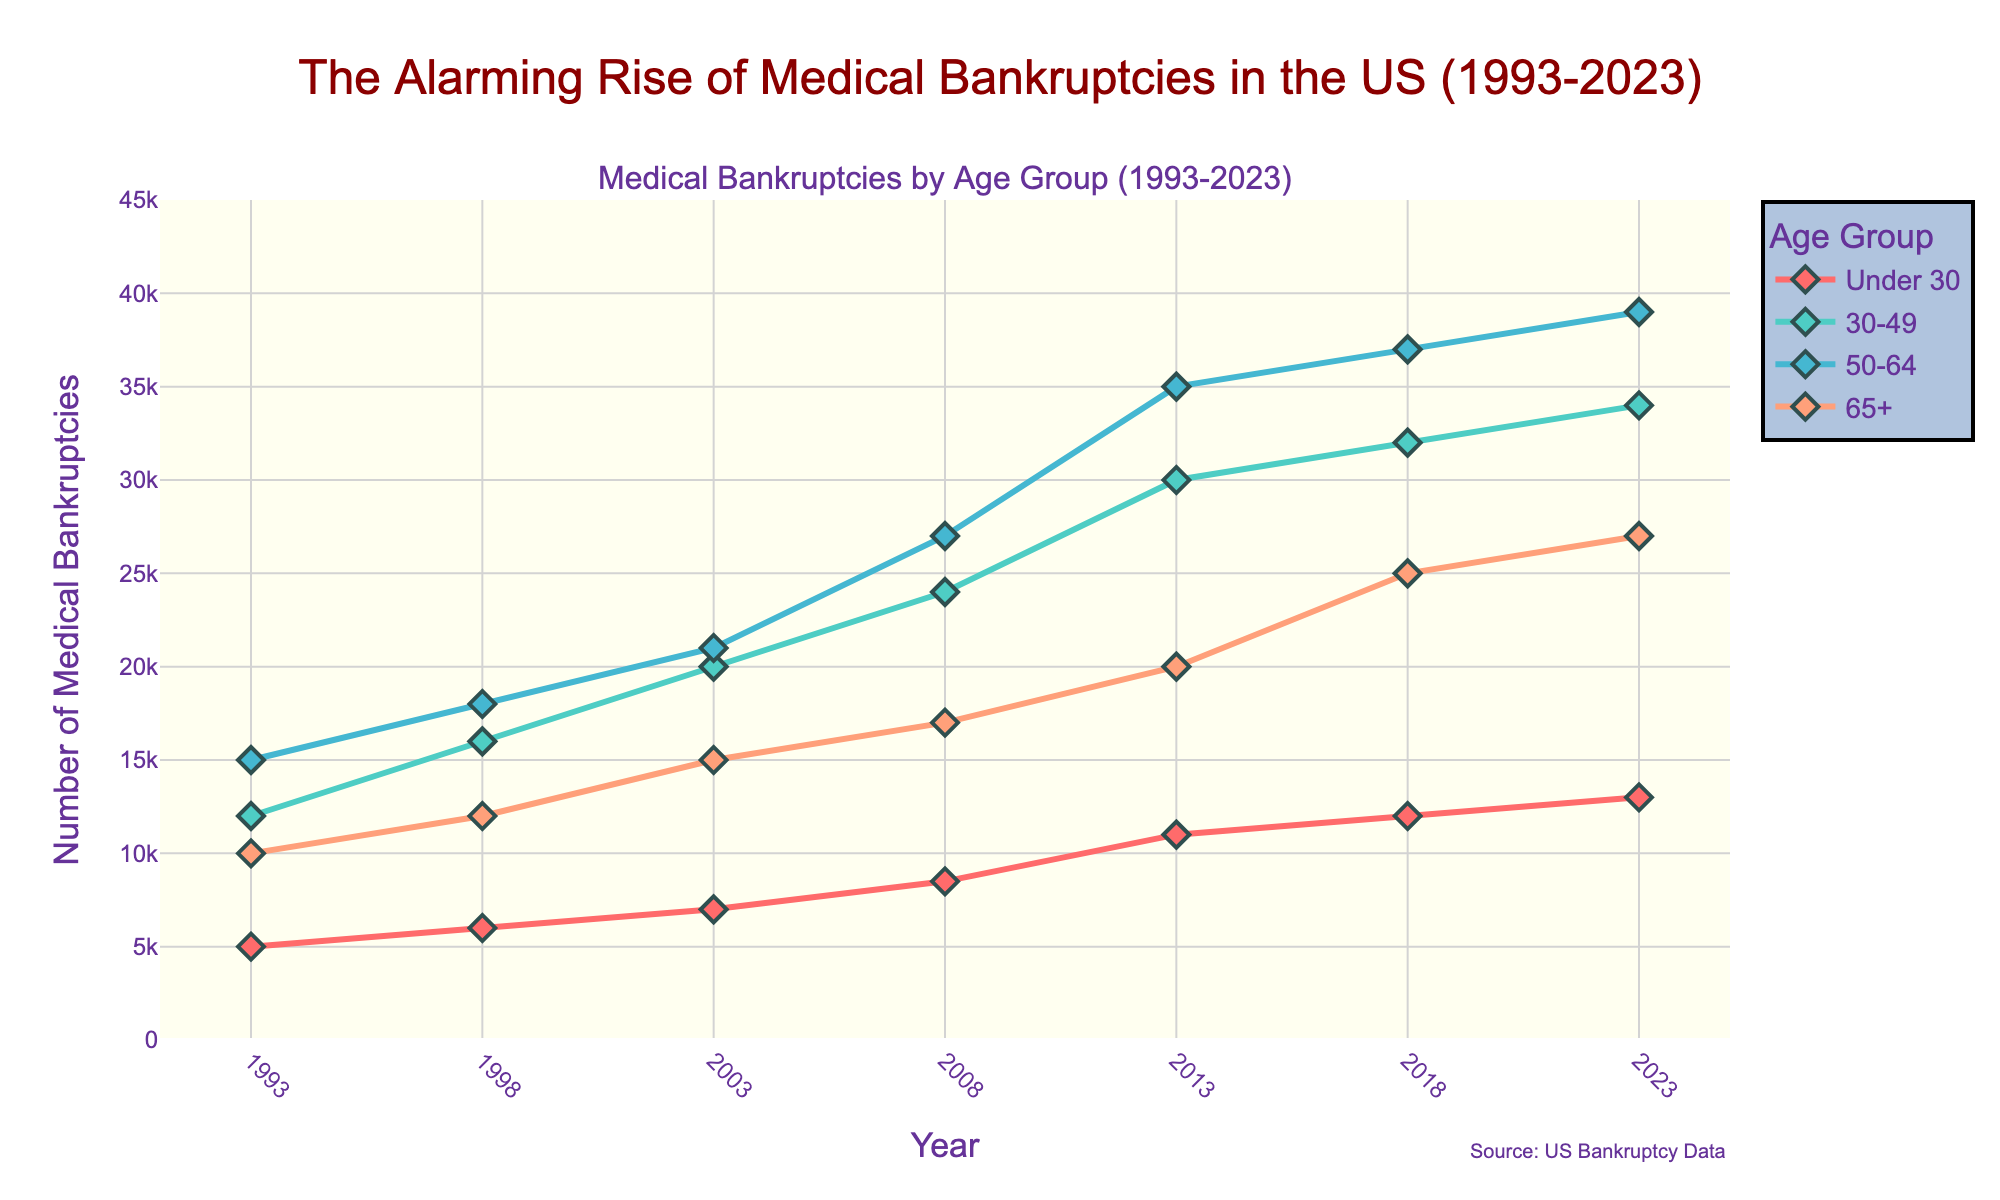How has the number of medical bankruptcies in the 50-64 age group changed from 1993 to 2023? The figure shows the values for the 50-64 age group at different years. In 1993, it's around 15,000 and by 2023, it's around 39,000. The change can be calculated as 39,000 - 15,000 = 24,000.
Answer: 24,000 Which age group had the highest number of medical bankruptcies in 2023? In the figure, we see that in 2023, the 50-64 age group had the highest number of medical bankruptcies, with around 39,000. Other age groups had fewer bankruptcies.
Answer: 50-64 What is the overall trend in medical bankruptcies for the 30-49 age group from 1993 to 2023? Observing the figure, the 30-49 age group sees an increase in medical bankruptcies from 12,000 in 1993 to 34,000 in 2023. The trend is consistently upward over the 30-year period.
Answer: Increasing Are medical bankruptcies increasing or decreasing for the age group Under 30 from 1993 to 2023? The figure indicates that medical bankruptcies for the Under 30 age group rose from 5,000 in 1993 to 13,000 in 2023, showing an overall increasing trend.
Answer: Increasing Which age group had the lowest number of medical bankruptcies in 1993, and what is that number? In 1993, the Under 30 age group had the lowest number of medical bankruptcies, with a value of 5,000, as inferred from the figure.
Answer: Under 30, 5,000 Compare the growth rate of medical bankruptcies for the 65+ age group between 1993 and 2023 with the Under 30 age group. Which is higher? For the 65+ age group, it went from 10,000 in 1993 to 27,000 in 2023. For the Under 30 group, it went from 5,000 to 13,000. The growth rates are therefore (27,000 - 10,000) / 10,000 = 1.7 and (13,000 - 5,000) / 5,000 = 1.6 respectively. The 65+ group has a slightly higher growth rate.
Answer: 65+ What is the approximate difference in medical bankruptcies between the 50-64 and 65+ age groups in 2023? The figure shows that in 2023, the 50-64 age group had about 39,000 bankruptcies, while the 65+ group had about 27,000. The difference is 39,000 - 27,000 = 12,000.
Answer: 12,000 Did any age group experience a decrease in the number of medical bankruptcies at any point between 1993 and 2023? By visual inspection of the figure, none of the age groups experienced a decrease. Each group shows a general upward trend throughout the time period.
Answer: No 